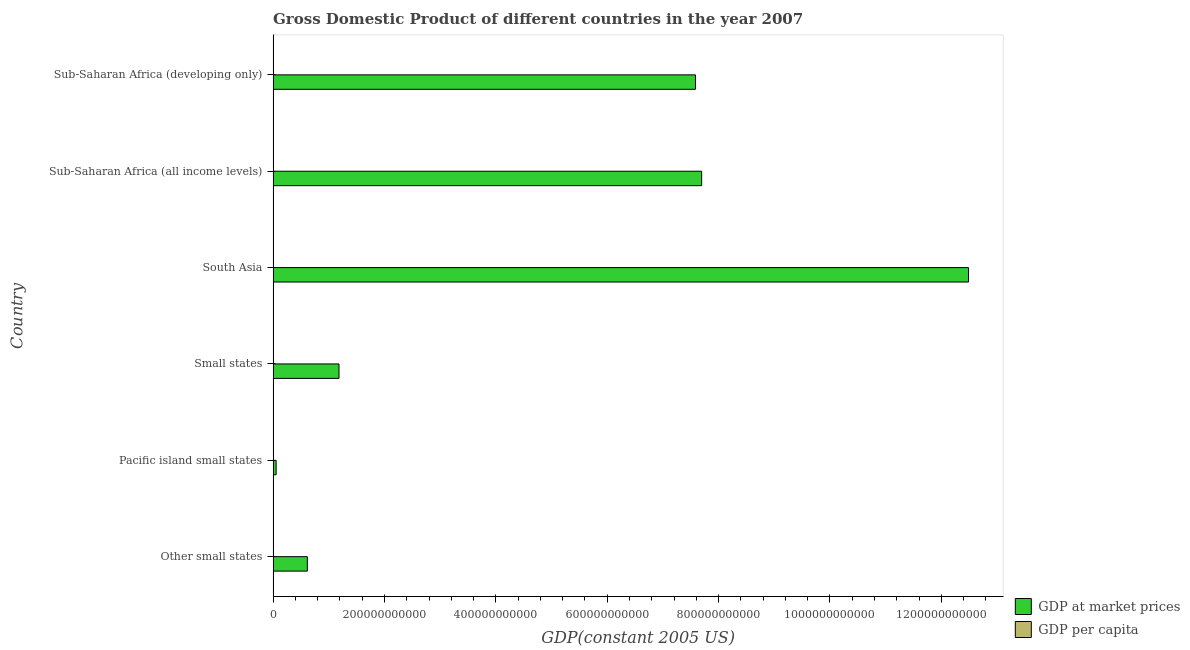How many different coloured bars are there?
Ensure brevity in your answer.  2. Are the number of bars on each tick of the Y-axis equal?
Offer a terse response. Yes. What is the label of the 2nd group of bars from the top?
Offer a very short reply. Sub-Saharan Africa (all income levels). What is the gdp per capita in Other small states?
Your answer should be compact. 3347.53. Across all countries, what is the maximum gdp per capita?
Provide a succinct answer. 4352.07. Across all countries, what is the minimum gdp at market prices?
Provide a succinct answer. 5.42e+09. In which country was the gdp at market prices minimum?
Your answer should be compact. Pacific island small states. What is the total gdp per capita in the graph?
Keep it short and to the point. 1.30e+04. What is the difference between the gdp at market prices in Pacific island small states and that in Sub-Saharan Africa (developing only)?
Your answer should be very brief. -7.53e+11. What is the difference between the gdp at market prices in Small states and the gdp per capita in Other small states?
Offer a terse response. 1.18e+11. What is the average gdp per capita per country?
Keep it short and to the point. 2160.76. What is the difference between the gdp per capita and gdp at market prices in Other small states?
Your response must be concise. -6.14e+1. In how many countries, is the gdp at market prices greater than 960000000000 US$?
Provide a succinct answer. 1. What is the ratio of the gdp per capita in Other small states to that in South Asia?
Provide a succinct answer. 4.18. Is the gdp per capita in South Asia less than that in Sub-Saharan Africa (all income levels)?
Give a very brief answer. Yes. What is the difference between the highest and the second highest gdp per capita?
Offer a very short reply. 1004.54. What is the difference between the highest and the lowest gdp at market prices?
Your answer should be very brief. 1.24e+12. In how many countries, is the gdp at market prices greater than the average gdp at market prices taken over all countries?
Make the answer very short. 3. What does the 2nd bar from the top in Pacific island small states represents?
Your answer should be very brief. GDP at market prices. What does the 2nd bar from the bottom in Pacific island small states represents?
Your answer should be compact. GDP per capita. What is the difference between two consecutive major ticks on the X-axis?
Give a very brief answer. 2.00e+11. Are the values on the major ticks of X-axis written in scientific E-notation?
Offer a very short reply. No. Does the graph contain grids?
Your answer should be very brief. No. Where does the legend appear in the graph?
Provide a succinct answer. Bottom right. How are the legend labels stacked?
Your answer should be compact. Vertical. What is the title of the graph?
Ensure brevity in your answer.  Gross Domestic Product of different countries in the year 2007. Does "Residents" appear as one of the legend labels in the graph?
Provide a succinct answer. No. What is the label or title of the X-axis?
Provide a succinct answer. GDP(constant 2005 US). What is the label or title of the Y-axis?
Give a very brief answer. Country. What is the GDP(constant 2005 US) in GDP at market prices in Other small states?
Offer a very short reply. 6.14e+1. What is the GDP(constant 2005 US) in GDP per capita in Other small states?
Ensure brevity in your answer.  3347.53. What is the GDP(constant 2005 US) in GDP at market prices in Pacific island small states?
Your answer should be very brief. 5.42e+09. What is the GDP(constant 2005 US) of GDP per capita in Pacific island small states?
Offer a very short reply. 2564.92. What is the GDP(constant 2005 US) in GDP at market prices in Small states?
Your answer should be compact. 1.18e+11. What is the GDP(constant 2005 US) in GDP per capita in Small states?
Your answer should be compact. 4352.07. What is the GDP(constant 2005 US) of GDP at market prices in South Asia?
Ensure brevity in your answer.  1.25e+12. What is the GDP(constant 2005 US) in GDP per capita in South Asia?
Offer a very short reply. 801.02. What is the GDP(constant 2005 US) in GDP at market prices in Sub-Saharan Africa (all income levels)?
Provide a short and direct response. 7.70e+11. What is the GDP(constant 2005 US) in GDP per capita in Sub-Saharan Africa (all income levels)?
Offer a very short reply. 955.98. What is the GDP(constant 2005 US) of GDP at market prices in Sub-Saharan Africa (developing only)?
Your answer should be compact. 7.58e+11. What is the GDP(constant 2005 US) of GDP per capita in Sub-Saharan Africa (developing only)?
Provide a short and direct response. 943.06. Across all countries, what is the maximum GDP(constant 2005 US) in GDP at market prices?
Ensure brevity in your answer.  1.25e+12. Across all countries, what is the maximum GDP(constant 2005 US) of GDP per capita?
Your answer should be compact. 4352.07. Across all countries, what is the minimum GDP(constant 2005 US) in GDP at market prices?
Your answer should be very brief. 5.42e+09. Across all countries, what is the minimum GDP(constant 2005 US) in GDP per capita?
Make the answer very short. 801.02. What is the total GDP(constant 2005 US) of GDP at market prices in the graph?
Give a very brief answer. 2.96e+12. What is the total GDP(constant 2005 US) of GDP per capita in the graph?
Give a very brief answer. 1.30e+04. What is the difference between the GDP(constant 2005 US) in GDP at market prices in Other small states and that in Pacific island small states?
Ensure brevity in your answer.  5.60e+1. What is the difference between the GDP(constant 2005 US) in GDP per capita in Other small states and that in Pacific island small states?
Your answer should be very brief. 782.61. What is the difference between the GDP(constant 2005 US) in GDP at market prices in Other small states and that in Small states?
Provide a short and direct response. -5.69e+1. What is the difference between the GDP(constant 2005 US) in GDP per capita in Other small states and that in Small states?
Your answer should be compact. -1004.54. What is the difference between the GDP(constant 2005 US) of GDP at market prices in Other small states and that in South Asia?
Give a very brief answer. -1.19e+12. What is the difference between the GDP(constant 2005 US) in GDP per capita in Other small states and that in South Asia?
Make the answer very short. 2546.51. What is the difference between the GDP(constant 2005 US) of GDP at market prices in Other small states and that in Sub-Saharan Africa (all income levels)?
Make the answer very short. -7.08e+11. What is the difference between the GDP(constant 2005 US) of GDP per capita in Other small states and that in Sub-Saharan Africa (all income levels)?
Your answer should be very brief. 2391.55. What is the difference between the GDP(constant 2005 US) of GDP at market prices in Other small states and that in Sub-Saharan Africa (developing only)?
Your answer should be compact. -6.97e+11. What is the difference between the GDP(constant 2005 US) of GDP per capita in Other small states and that in Sub-Saharan Africa (developing only)?
Your answer should be compact. 2404.47. What is the difference between the GDP(constant 2005 US) in GDP at market prices in Pacific island small states and that in Small states?
Offer a terse response. -1.13e+11. What is the difference between the GDP(constant 2005 US) of GDP per capita in Pacific island small states and that in Small states?
Your answer should be compact. -1787.15. What is the difference between the GDP(constant 2005 US) in GDP at market prices in Pacific island small states and that in South Asia?
Your answer should be compact. -1.24e+12. What is the difference between the GDP(constant 2005 US) of GDP per capita in Pacific island small states and that in South Asia?
Your answer should be compact. 1763.89. What is the difference between the GDP(constant 2005 US) in GDP at market prices in Pacific island small states and that in Sub-Saharan Africa (all income levels)?
Your response must be concise. -7.64e+11. What is the difference between the GDP(constant 2005 US) in GDP per capita in Pacific island small states and that in Sub-Saharan Africa (all income levels)?
Offer a terse response. 1608.93. What is the difference between the GDP(constant 2005 US) of GDP at market prices in Pacific island small states and that in Sub-Saharan Africa (developing only)?
Offer a terse response. -7.53e+11. What is the difference between the GDP(constant 2005 US) of GDP per capita in Pacific island small states and that in Sub-Saharan Africa (developing only)?
Provide a short and direct response. 1621.85. What is the difference between the GDP(constant 2005 US) in GDP at market prices in Small states and that in South Asia?
Provide a short and direct response. -1.13e+12. What is the difference between the GDP(constant 2005 US) in GDP per capita in Small states and that in South Asia?
Make the answer very short. 3551.05. What is the difference between the GDP(constant 2005 US) of GDP at market prices in Small states and that in Sub-Saharan Africa (all income levels)?
Offer a terse response. -6.51e+11. What is the difference between the GDP(constant 2005 US) in GDP per capita in Small states and that in Sub-Saharan Africa (all income levels)?
Offer a terse response. 3396.09. What is the difference between the GDP(constant 2005 US) in GDP at market prices in Small states and that in Sub-Saharan Africa (developing only)?
Ensure brevity in your answer.  -6.40e+11. What is the difference between the GDP(constant 2005 US) of GDP per capita in Small states and that in Sub-Saharan Africa (developing only)?
Your answer should be compact. 3409.01. What is the difference between the GDP(constant 2005 US) of GDP at market prices in South Asia and that in Sub-Saharan Africa (all income levels)?
Offer a terse response. 4.79e+11. What is the difference between the GDP(constant 2005 US) in GDP per capita in South Asia and that in Sub-Saharan Africa (all income levels)?
Keep it short and to the point. -154.96. What is the difference between the GDP(constant 2005 US) in GDP at market prices in South Asia and that in Sub-Saharan Africa (developing only)?
Ensure brevity in your answer.  4.90e+11. What is the difference between the GDP(constant 2005 US) in GDP per capita in South Asia and that in Sub-Saharan Africa (developing only)?
Offer a very short reply. -142.04. What is the difference between the GDP(constant 2005 US) of GDP at market prices in Sub-Saharan Africa (all income levels) and that in Sub-Saharan Africa (developing only)?
Your answer should be very brief. 1.11e+1. What is the difference between the GDP(constant 2005 US) of GDP per capita in Sub-Saharan Africa (all income levels) and that in Sub-Saharan Africa (developing only)?
Your answer should be compact. 12.92. What is the difference between the GDP(constant 2005 US) of GDP at market prices in Other small states and the GDP(constant 2005 US) of GDP per capita in Pacific island small states?
Offer a terse response. 6.14e+1. What is the difference between the GDP(constant 2005 US) in GDP at market prices in Other small states and the GDP(constant 2005 US) in GDP per capita in Small states?
Offer a terse response. 6.14e+1. What is the difference between the GDP(constant 2005 US) of GDP at market prices in Other small states and the GDP(constant 2005 US) of GDP per capita in South Asia?
Make the answer very short. 6.14e+1. What is the difference between the GDP(constant 2005 US) in GDP at market prices in Other small states and the GDP(constant 2005 US) in GDP per capita in Sub-Saharan Africa (all income levels)?
Provide a short and direct response. 6.14e+1. What is the difference between the GDP(constant 2005 US) in GDP at market prices in Other small states and the GDP(constant 2005 US) in GDP per capita in Sub-Saharan Africa (developing only)?
Provide a succinct answer. 6.14e+1. What is the difference between the GDP(constant 2005 US) in GDP at market prices in Pacific island small states and the GDP(constant 2005 US) in GDP per capita in Small states?
Offer a very short reply. 5.42e+09. What is the difference between the GDP(constant 2005 US) in GDP at market prices in Pacific island small states and the GDP(constant 2005 US) in GDP per capita in South Asia?
Keep it short and to the point. 5.42e+09. What is the difference between the GDP(constant 2005 US) of GDP at market prices in Pacific island small states and the GDP(constant 2005 US) of GDP per capita in Sub-Saharan Africa (all income levels)?
Provide a succinct answer. 5.42e+09. What is the difference between the GDP(constant 2005 US) in GDP at market prices in Pacific island small states and the GDP(constant 2005 US) in GDP per capita in Sub-Saharan Africa (developing only)?
Your response must be concise. 5.42e+09. What is the difference between the GDP(constant 2005 US) of GDP at market prices in Small states and the GDP(constant 2005 US) of GDP per capita in South Asia?
Provide a short and direct response. 1.18e+11. What is the difference between the GDP(constant 2005 US) of GDP at market prices in Small states and the GDP(constant 2005 US) of GDP per capita in Sub-Saharan Africa (all income levels)?
Provide a short and direct response. 1.18e+11. What is the difference between the GDP(constant 2005 US) in GDP at market prices in Small states and the GDP(constant 2005 US) in GDP per capita in Sub-Saharan Africa (developing only)?
Provide a short and direct response. 1.18e+11. What is the difference between the GDP(constant 2005 US) of GDP at market prices in South Asia and the GDP(constant 2005 US) of GDP per capita in Sub-Saharan Africa (all income levels)?
Offer a very short reply. 1.25e+12. What is the difference between the GDP(constant 2005 US) of GDP at market prices in South Asia and the GDP(constant 2005 US) of GDP per capita in Sub-Saharan Africa (developing only)?
Offer a terse response. 1.25e+12. What is the difference between the GDP(constant 2005 US) of GDP at market prices in Sub-Saharan Africa (all income levels) and the GDP(constant 2005 US) of GDP per capita in Sub-Saharan Africa (developing only)?
Offer a very short reply. 7.70e+11. What is the average GDP(constant 2005 US) of GDP at market prices per country?
Provide a succinct answer. 4.94e+11. What is the average GDP(constant 2005 US) of GDP per capita per country?
Give a very brief answer. 2160.77. What is the difference between the GDP(constant 2005 US) of GDP at market prices and GDP(constant 2005 US) of GDP per capita in Other small states?
Offer a very short reply. 6.14e+1. What is the difference between the GDP(constant 2005 US) of GDP at market prices and GDP(constant 2005 US) of GDP per capita in Pacific island small states?
Your answer should be very brief. 5.42e+09. What is the difference between the GDP(constant 2005 US) in GDP at market prices and GDP(constant 2005 US) in GDP per capita in Small states?
Provide a short and direct response. 1.18e+11. What is the difference between the GDP(constant 2005 US) of GDP at market prices and GDP(constant 2005 US) of GDP per capita in South Asia?
Provide a succinct answer. 1.25e+12. What is the difference between the GDP(constant 2005 US) in GDP at market prices and GDP(constant 2005 US) in GDP per capita in Sub-Saharan Africa (all income levels)?
Offer a terse response. 7.70e+11. What is the difference between the GDP(constant 2005 US) of GDP at market prices and GDP(constant 2005 US) of GDP per capita in Sub-Saharan Africa (developing only)?
Offer a very short reply. 7.58e+11. What is the ratio of the GDP(constant 2005 US) of GDP at market prices in Other small states to that in Pacific island small states?
Ensure brevity in your answer.  11.32. What is the ratio of the GDP(constant 2005 US) of GDP per capita in Other small states to that in Pacific island small states?
Keep it short and to the point. 1.31. What is the ratio of the GDP(constant 2005 US) of GDP at market prices in Other small states to that in Small states?
Ensure brevity in your answer.  0.52. What is the ratio of the GDP(constant 2005 US) in GDP per capita in Other small states to that in Small states?
Ensure brevity in your answer.  0.77. What is the ratio of the GDP(constant 2005 US) of GDP at market prices in Other small states to that in South Asia?
Offer a terse response. 0.05. What is the ratio of the GDP(constant 2005 US) of GDP per capita in Other small states to that in South Asia?
Make the answer very short. 4.18. What is the ratio of the GDP(constant 2005 US) of GDP at market prices in Other small states to that in Sub-Saharan Africa (all income levels)?
Offer a terse response. 0.08. What is the ratio of the GDP(constant 2005 US) in GDP per capita in Other small states to that in Sub-Saharan Africa (all income levels)?
Provide a succinct answer. 3.5. What is the ratio of the GDP(constant 2005 US) of GDP at market prices in Other small states to that in Sub-Saharan Africa (developing only)?
Provide a succinct answer. 0.08. What is the ratio of the GDP(constant 2005 US) in GDP per capita in Other small states to that in Sub-Saharan Africa (developing only)?
Provide a succinct answer. 3.55. What is the ratio of the GDP(constant 2005 US) in GDP at market prices in Pacific island small states to that in Small states?
Ensure brevity in your answer.  0.05. What is the ratio of the GDP(constant 2005 US) in GDP per capita in Pacific island small states to that in Small states?
Give a very brief answer. 0.59. What is the ratio of the GDP(constant 2005 US) in GDP at market prices in Pacific island small states to that in South Asia?
Provide a short and direct response. 0. What is the ratio of the GDP(constant 2005 US) in GDP per capita in Pacific island small states to that in South Asia?
Ensure brevity in your answer.  3.2. What is the ratio of the GDP(constant 2005 US) of GDP at market prices in Pacific island small states to that in Sub-Saharan Africa (all income levels)?
Provide a succinct answer. 0.01. What is the ratio of the GDP(constant 2005 US) of GDP per capita in Pacific island small states to that in Sub-Saharan Africa (all income levels)?
Provide a short and direct response. 2.68. What is the ratio of the GDP(constant 2005 US) of GDP at market prices in Pacific island small states to that in Sub-Saharan Africa (developing only)?
Provide a short and direct response. 0.01. What is the ratio of the GDP(constant 2005 US) in GDP per capita in Pacific island small states to that in Sub-Saharan Africa (developing only)?
Give a very brief answer. 2.72. What is the ratio of the GDP(constant 2005 US) of GDP at market prices in Small states to that in South Asia?
Offer a very short reply. 0.09. What is the ratio of the GDP(constant 2005 US) in GDP per capita in Small states to that in South Asia?
Provide a succinct answer. 5.43. What is the ratio of the GDP(constant 2005 US) of GDP at market prices in Small states to that in Sub-Saharan Africa (all income levels)?
Your response must be concise. 0.15. What is the ratio of the GDP(constant 2005 US) of GDP per capita in Small states to that in Sub-Saharan Africa (all income levels)?
Offer a terse response. 4.55. What is the ratio of the GDP(constant 2005 US) of GDP at market prices in Small states to that in Sub-Saharan Africa (developing only)?
Your answer should be very brief. 0.16. What is the ratio of the GDP(constant 2005 US) in GDP per capita in Small states to that in Sub-Saharan Africa (developing only)?
Give a very brief answer. 4.61. What is the ratio of the GDP(constant 2005 US) of GDP at market prices in South Asia to that in Sub-Saharan Africa (all income levels)?
Offer a very short reply. 1.62. What is the ratio of the GDP(constant 2005 US) in GDP per capita in South Asia to that in Sub-Saharan Africa (all income levels)?
Your answer should be very brief. 0.84. What is the ratio of the GDP(constant 2005 US) of GDP at market prices in South Asia to that in Sub-Saharan Africa (developing only)?
Your answer should be compact. 1.65. What is the ratio of the GDP(constant 2005 US) of GDP per capita in South Asia to that in Sub-Saharan Africa (developing only)?
Your answer should be very brief. 0.85. What is the ratio of the GDP(constant 2005 US) of GDP at market prices in Sub-Saharan Africa (all income levels) to that in Sub-Saharan Africa (developing only)?
Give a very brief answer. 1.01. What is the ratio of the GDP(constant 2005 US) in GDP per capita in Sub-Saharan Africa (all income levels) to that in Sub-Saharan Africa (developing only)?
Ensure brevity in your answer.  1.01. What is the difference between the highest and the second highest GDP(constant 2005 US) of GDP at market prices?
Offer a very short reply. 4.79e+11. What is the difference between the highest and the second highest GDP(constant 2005 US) in GDP per capita?
Your answer should be compact. 1004.54. What is the difference between the highest and the lowest GDP(constant 2005 US) in GDP at market prices?
Make the answer very short. 1.24e+12. What is the difference between the highest and the lowest GDP(constant 2005 US) of GDP per capita?
Your answer should be compact. 3551.05. 